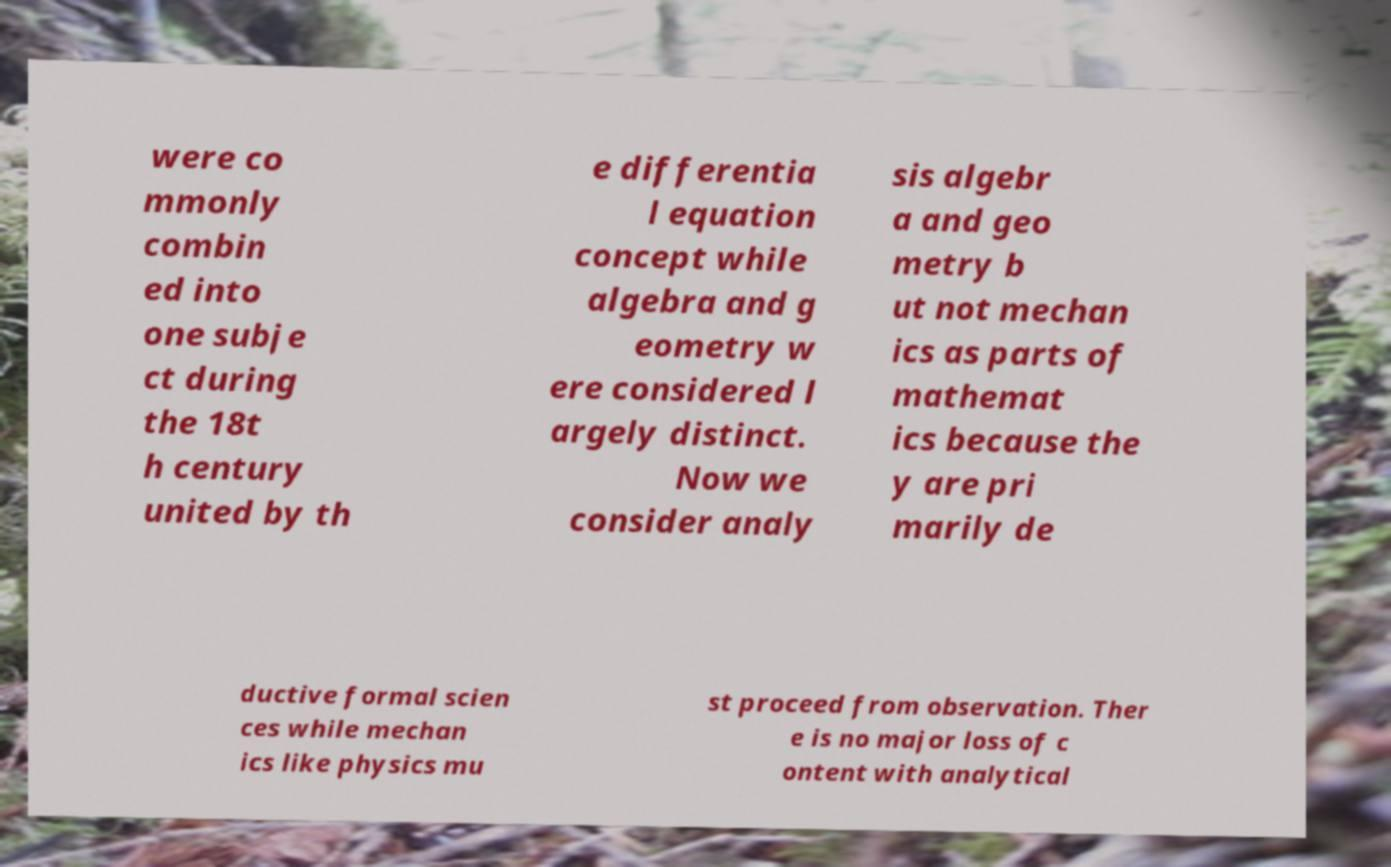Please identify and transcribe the text found in this image. were co mmonly combin ed into one subje ct during the 18t h century united by th e differentia l equation concept while algebra and g eometry w ere considered l argely distinct. Now we consider analy sis algebr a and geo metry b ut not mechan ics as parts of mathemat ics because the y are pri marily de ductive formal scien ces while mechan ics like physics mu st proceed from observation. Ther e is no major loss of c ontent with analytical 